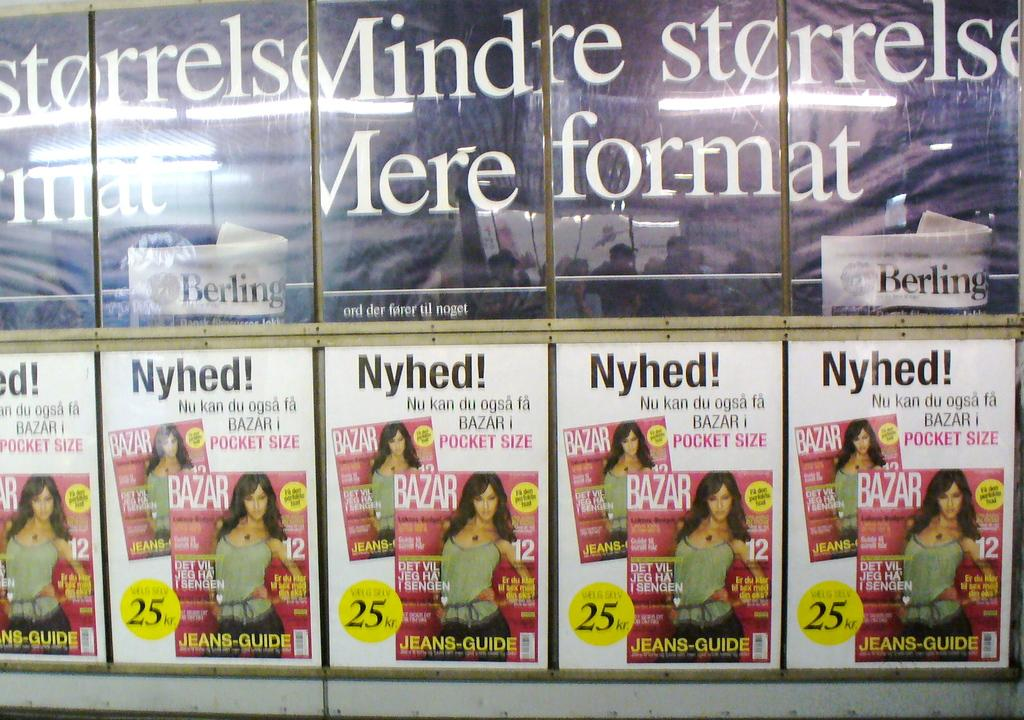<image>
Offer a succinct explanation of the picture presented. A woman is on the cover of multiple flyers and the words are in a foreign language 